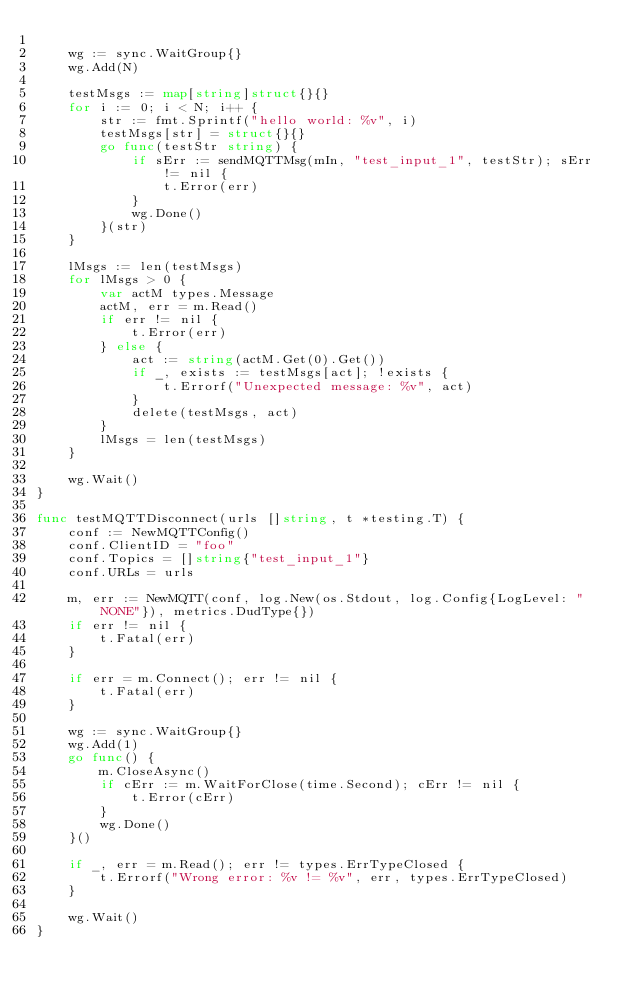Convert code to text. <code><loc_0><loc_0><loc_500><loc_500><_Go_>
	wg := sync.WaitGroup{}
	wg.Add(N)

	testMsgs := map[string]struct{}{}
	for i := 0; i < N; i++ {
		str := fmt.Sprintf("hello world: %v", i)
		testMsgs[str] = struct{}{}
		go func(testStr string) {
			if sErr := sendMQTTMsg(mIn, "test_input_1", testStr); sErr != nil {
				t.Error(err)
			}
			wg.Done()
		}(str)
	}

	lMsgs := len(testMsgs)
	for lMsgs > 0 {
		var actM types.Message
		actM, err = m.Read()
		if err != nil {
			t.Error(err)
		} else {
			act := string(actM.Get(0).Get())
			if _, exists := testMsgs[act]; !exists {
				t.Errorf("Unexpected message: %v", act)
			}
			delete(testMsgs, act)
		}
		lMsgs = len(testMsgs)
	}

	wg.Wait()
}

func testMQTTDisconnect(urls []string, t *testing.T) {
	conf := NewMQTTConfig()
	conf.ClientID = "foo"
	conf.Topics = []string{"test_input_1"}
	conf.URLs = urls

	m, err := NewMQTT(conf, log.New(os.Stdout, log.Config{LogLevel: "NONE"}), metrics.DudType{})
	if err != nil {
		t.Fatal(err)
	}

	if err = m.Connect(); err != nil {
		t.Fatal(err)
	}

	wg := sync.WaitGroup{}
	wg.Add(1)
	go func() {
		m.CloseAsync()
		if cErr := m.WaitForClose(time.Second); cErr != nil {
			t.Error(cErr)
		}
		wg.Done()
	}()

	if _, err = m.Read(); err != types.ErrTypeClosed {
		t.Errorf("Wrong error: %v != %v", err, types.ErrTypeClosed)
	}

	wg.Wait()
}
</code> 